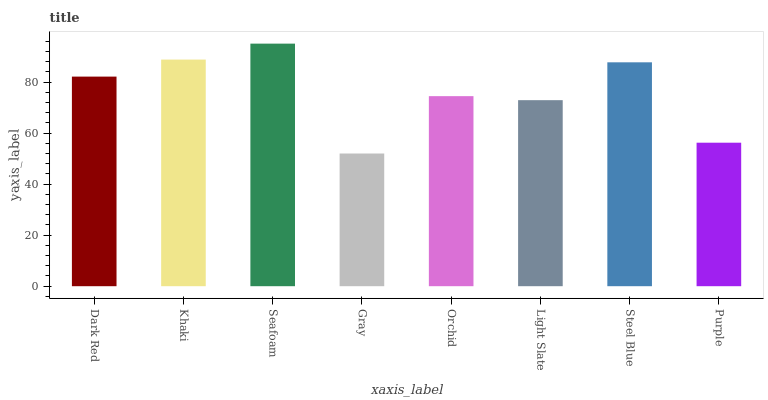Is Gray the minimum?
Answer yes or no. Yes. Is Seafoam the maximum?
Answer yes or no. Yes. Is Khaki the minimum?
Answer yes or no. No. Is Khaki the maximum?
Answer yes or no. No. Is Khaki greater than Dark Red?
Answer yes or no. Yes. Is Dark Red less than Khaki?
Answer yes or no. Yes. Is Dark Red greater than Khaki?
Answer yes or no. No. Is Khaki less than Dark Red?
Answer yes or no. No. Is Dark Red the high median?
Answer yes or no. Yes. Is Orchid the low median?
Answer yes or no. Yes. Is Gray the high median?
Answer yes or no. No. Is Purple the low median?
Answer yes or no. No. 